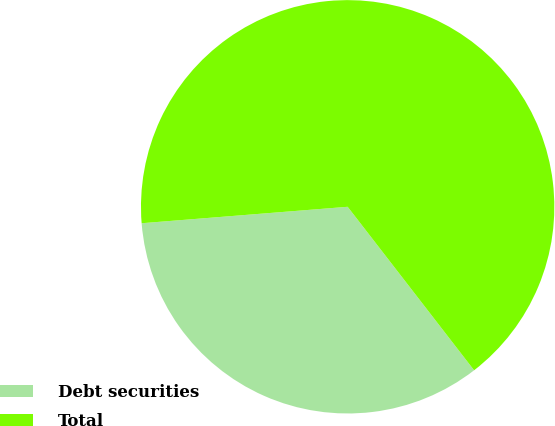<chart> <loc_0><loc_0><loc_500><loc_500><pie_chart><fcel>Debt securities<fcel>Total<nl><fcel>34.21%<fcel>65.79%<nl></chart> 